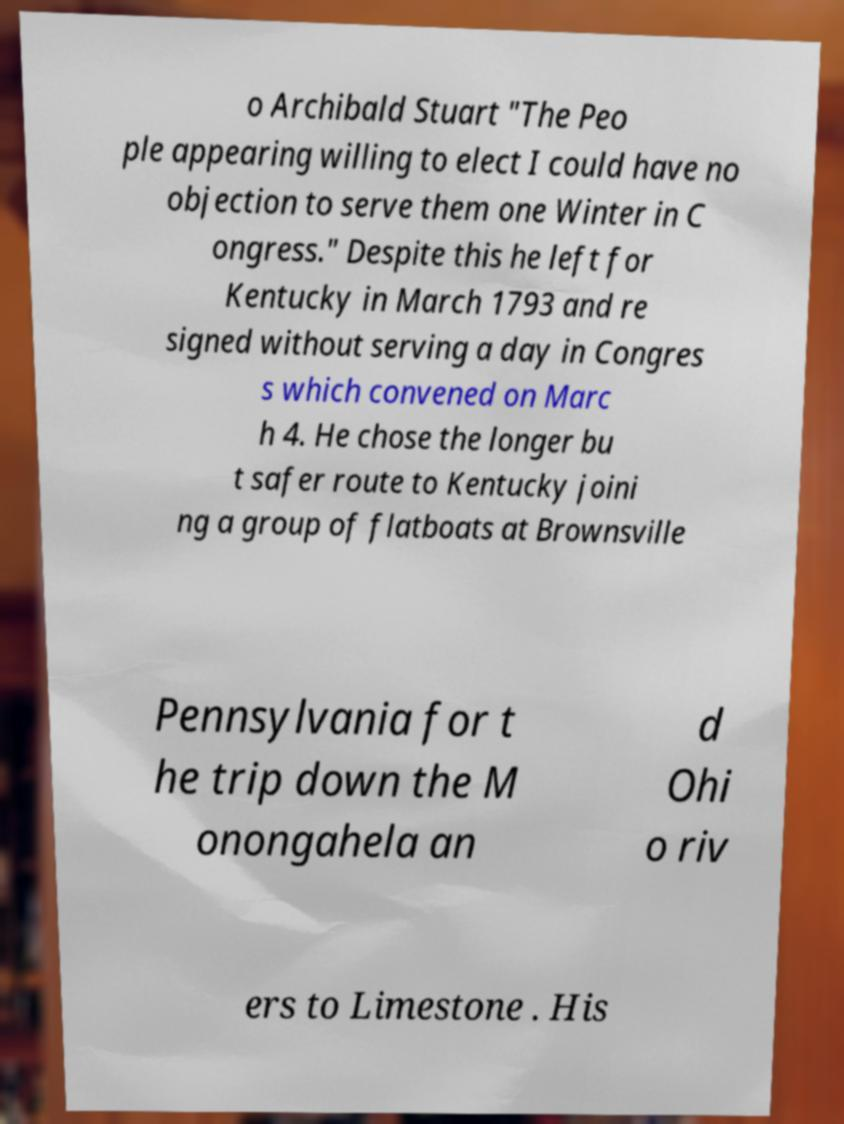Please identify and transcribe the text found in this image. o Archibald Stuart "The Peo ple appearing willing to elect I could have no objection to serve them one Winter in C ongress." Despite this he left for Kentucky in March 1793 and re signed without serving a day in Congres s which convened on Marc h 4. He chose the longer bu t safer route to Kentucky joini ng a group of flatboats at Brownsville Pennsylvania for t he trip down the M onongahela an d Ohi o riv ers to Limestone . His 